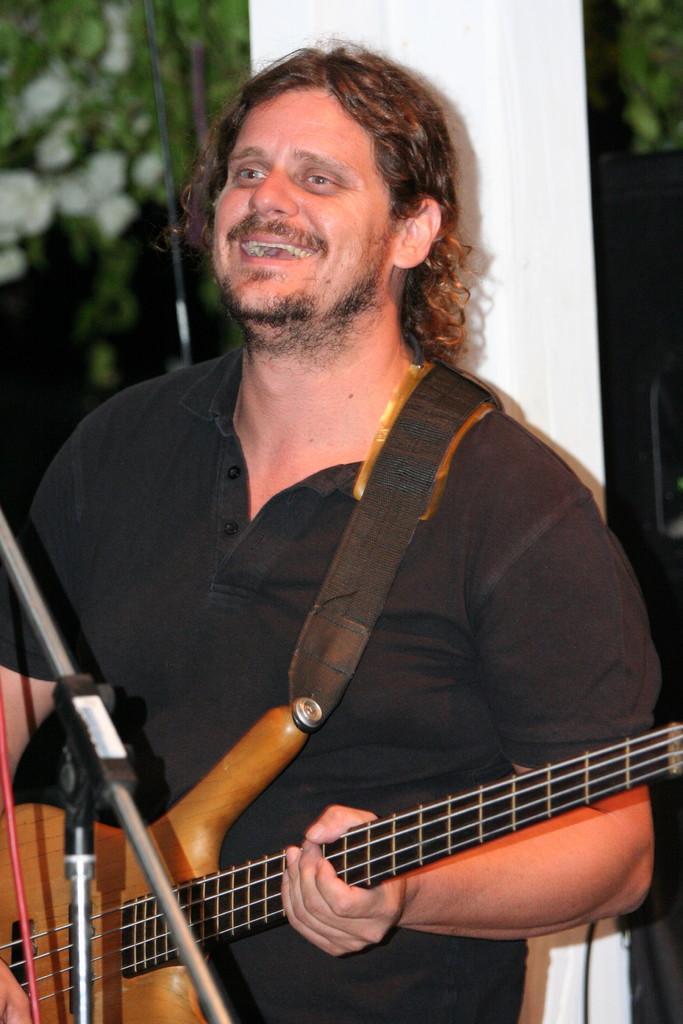Can you describe this image briefly? A man is standing by holding the guitar in his hands and he is smiling. 